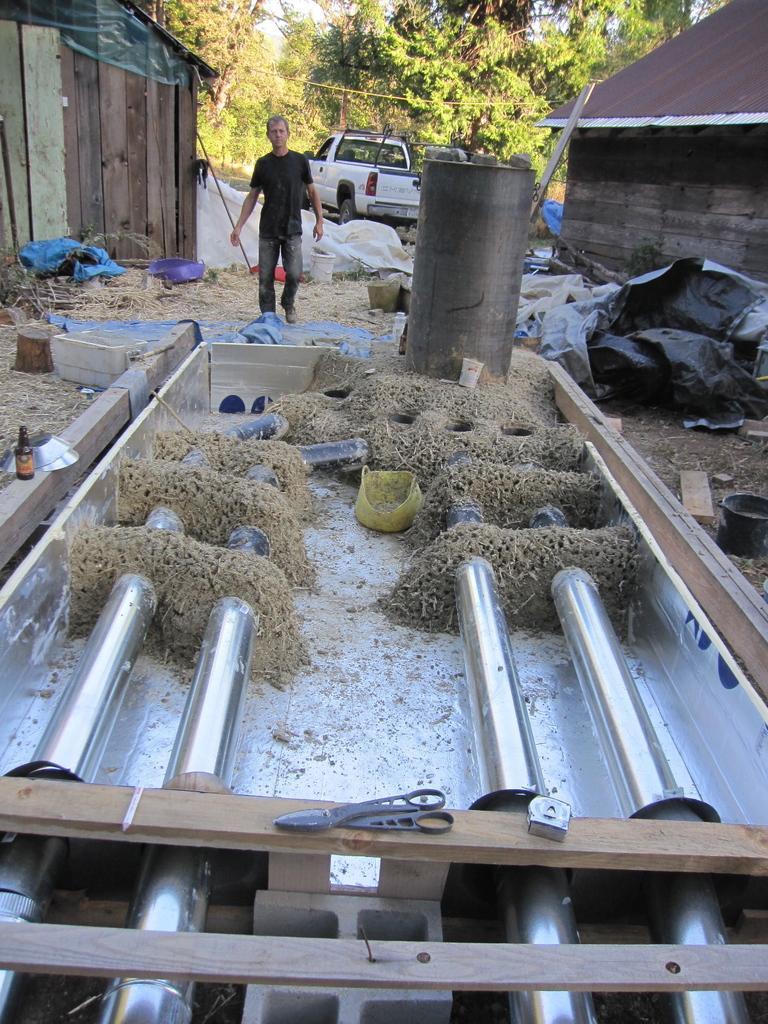Can you describe this image briefly? There is some product manufacturing is going on and there is a machine, in front of the machine, there is a drum. A person is walking in the opposite direction of the drum, on the left side and right side there are two wooden huts. There is a vehicle parked in between the huts. Behind the vehicle there are plenty of trees. 